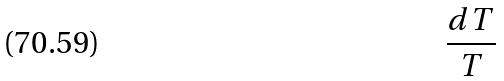Convert formula to latex. <formula><loc_0><loc_0><loc_500><loc_500>\frac { d T } { T }</formula> 